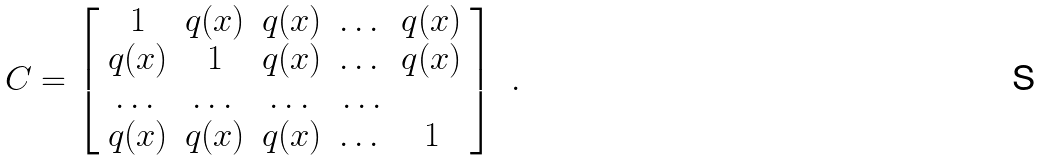<formula> <loc_0><loc_0><loc_500><loc_500>C = \left [ \begin{array} { c c c c c } 1 & q ( x ) & q ( x ) & \dots & q ( x ) \\ q ( x ) & 1 & q ( x ) & \dots & q ( x ) \\ \dots & \dots & \dots & \dots \\ q ( x ) & q ( x ) & q ( x ) & \dots & 1 \end{array} \right ] \ .</formula> 